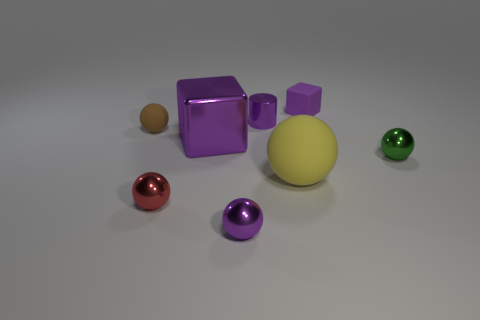Subtract all yellow spheres. How many spheres are left? 4 Subtract all tiny red spheres. How many spheres are left? 4 Subtract all cyan spheres. Subtract all yellow cylinders. How many spheres are left? 5 Add 2 gray rubber cylinders. How many objects exist? 10 Subtract all balls. How many objects are left? 3 Add 3 tiny purple balls. How many tiny purple balls are left? 4 Add 2 purple objects. How many purple objects exist? 6 Subtract 0 yellow cylinders. How many objects are left? 8 Subtract all small brown spheres. Subtract all purple rubber blocks. How many objects are left? 6 